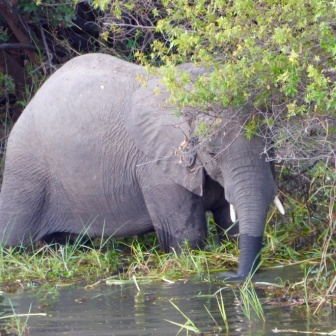Describe the surrounding environment in detail. The surrounding environment is a rich, verdant landscape. The area is replete with dense foliage, a mix of trees and shrubs providing a thick, green canopy. The water around the elephant is filled with various aquatic plants, creating a lively, natural scene. The habitat appears untouched by human activity, offering a pure representation of wilderness where the elephant can feel at home. The mix of land and water, coupled with the dense vegetation, suggests an ecosystem teeming with life. 